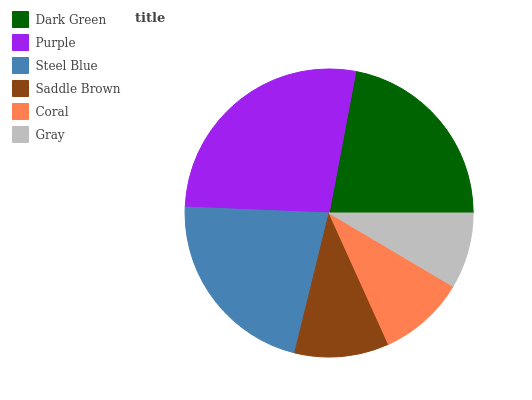Is Gray the minimum?
Answer yes or no. Yes. Is Purple the maximum?
Answer yes or no. Yes. Is Steel Blue the minimum?
Answer yes or no. No. Is Steel Blue the maximum?
Answer yes or no. No. Is Purple greater than Steel Blue?
Answer yes or no. Yes. Is Steel Blue less than Purple?
Answer yes or no. Yes. Is Steel Blue greater than Purple?
Answer yes or no. No. Is Purple less than Steel Blue?
Answer yes or no. No. Is Steel Blue the high median?
Answer yes or no. Yes. Is Saddle Brown the low median?
Answer yes or no. Yes. Is Gray the high median?
Answer yes or no. No. Is Coral the low median?
Answer yes or no. No. 